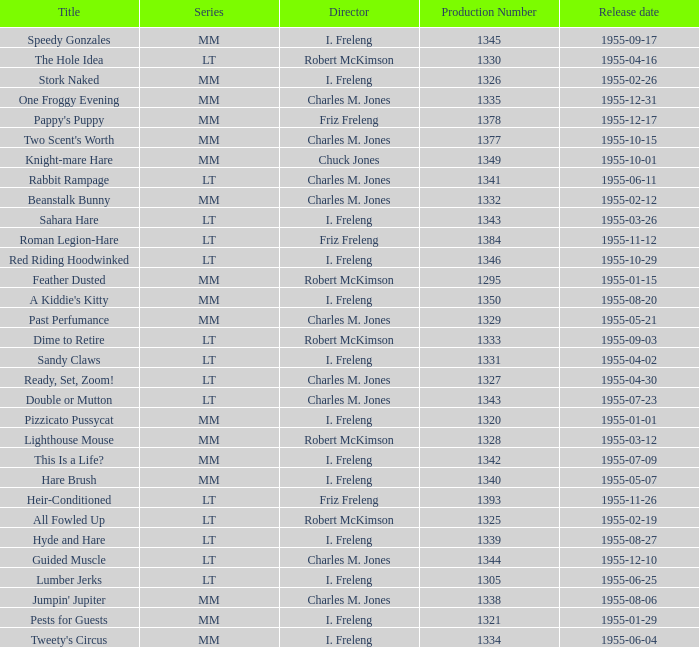What is the release date of production number 1327? 1955-04-30. 